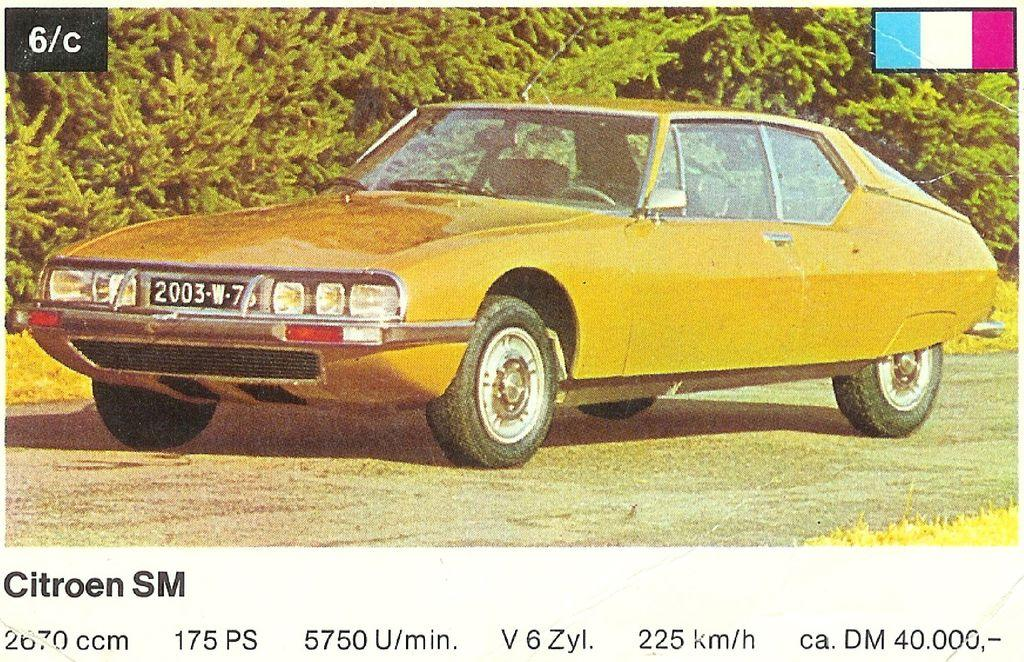What is the main subject of the image? The main subject of the image is a photograph of a car. What information is provided about the car in the image? There are specifications of the car mentioned beneath the photograph. What can be seen in the background of the image? There are trees visible behind the car. Can you tell me what the woman is thinking about the car in the image? There is no woman present in the image, so it is not possible to determine her thoughts about the car. 